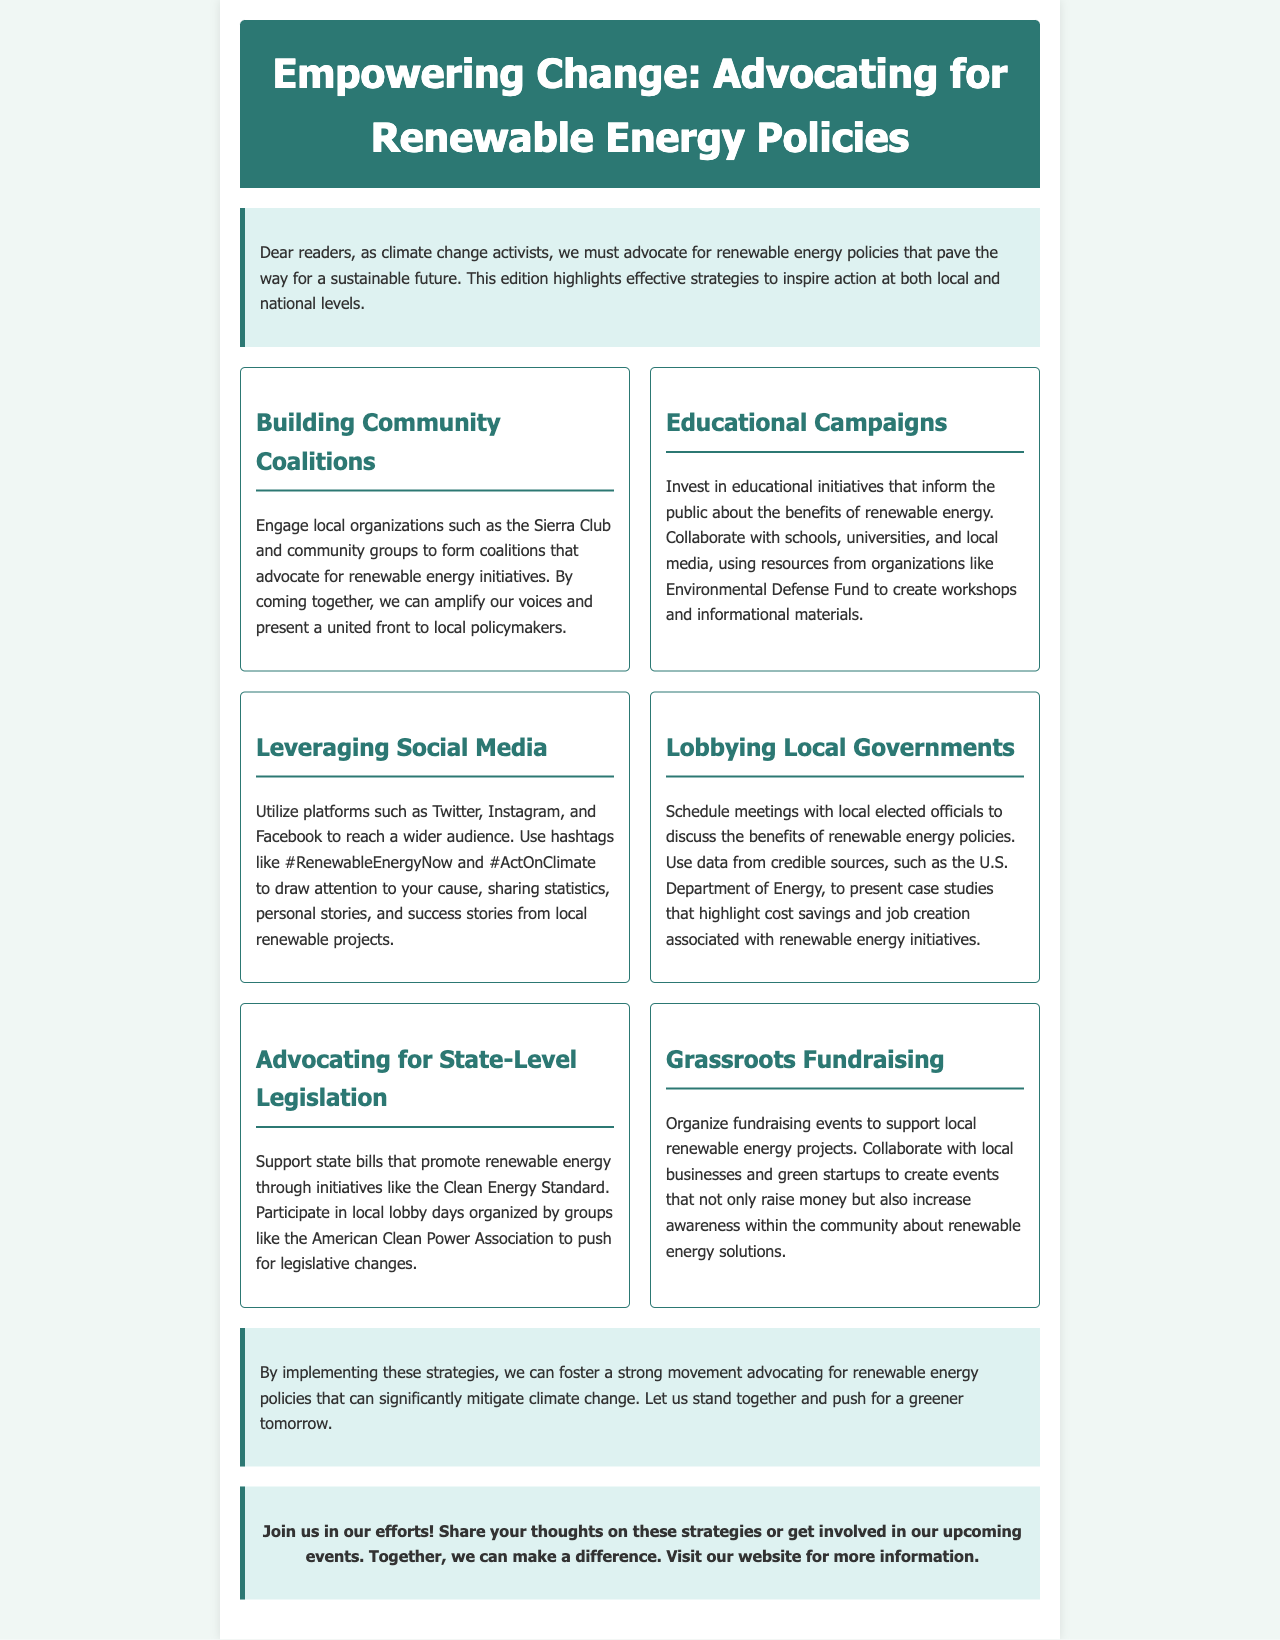what is the title of the newsletter? The title of the newsletter is prominently displayed at the top of the document.
Answer: Empowering Change: Advocating for Renewable Energy Policies how many strategies are listed in the newsletter? The newsletter outlines a total of six strategies in the strategies section.
Answer: 6 what is one organization mentioned for forming coalitions? The document specifies organizations that can help build community coalitions for advocacy.
Answer: Sierra Club which social media platforms are suggested for advocacy? The strategies suggest using popular social media platforms to reach a wider audience.
Answer: Twitter, Instagram, Facebook what is the purpose of grassroots fundraising mentioned in the newsletter? Grassroots fundraising aims to support local renewable energy projects and raise community awareness.
Answer: Support local renewable energy projects who should be scheduled for meetings to discuss renewable energy benefits? The document advises meeting with local elected officials to discuss the benefits of renewable energy.
Answer: Local elected officials what initiative is mentioned for state-level legislation support? The newsletter highlights a specific legislative initiative that promotes renewable energy at the state level.
Answer: Clean Energy Standard what type of campaigns should be invested in according to the document? The newsletter emphasizes the importance of campaigns designed to inform the public.
Answer: Educational Campaigns 